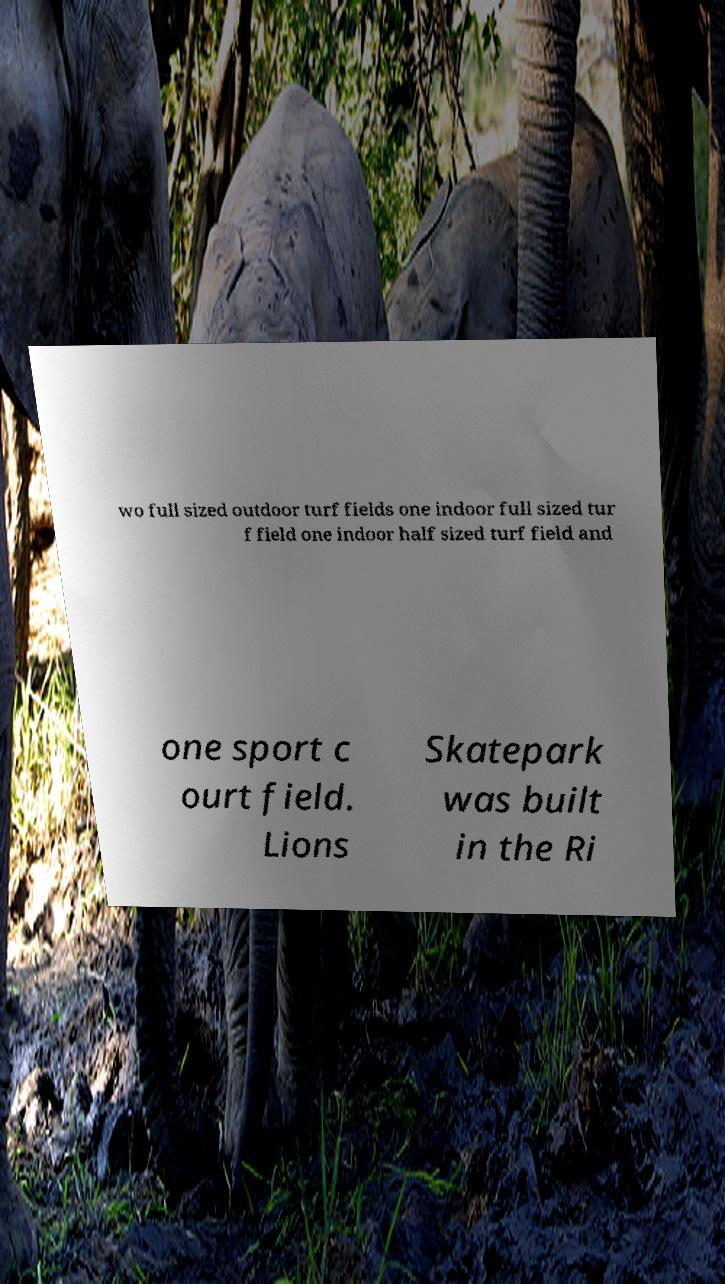Can you read and provide the text displayed in the image?This photo seems to have some interesting text. Can you extract and type it out for me? wo full sized outdoor turf fields one indoor full sized tur f field one indoor half sized turf field and one sport c ourt field. Lions Skatepark was built in the Ri 